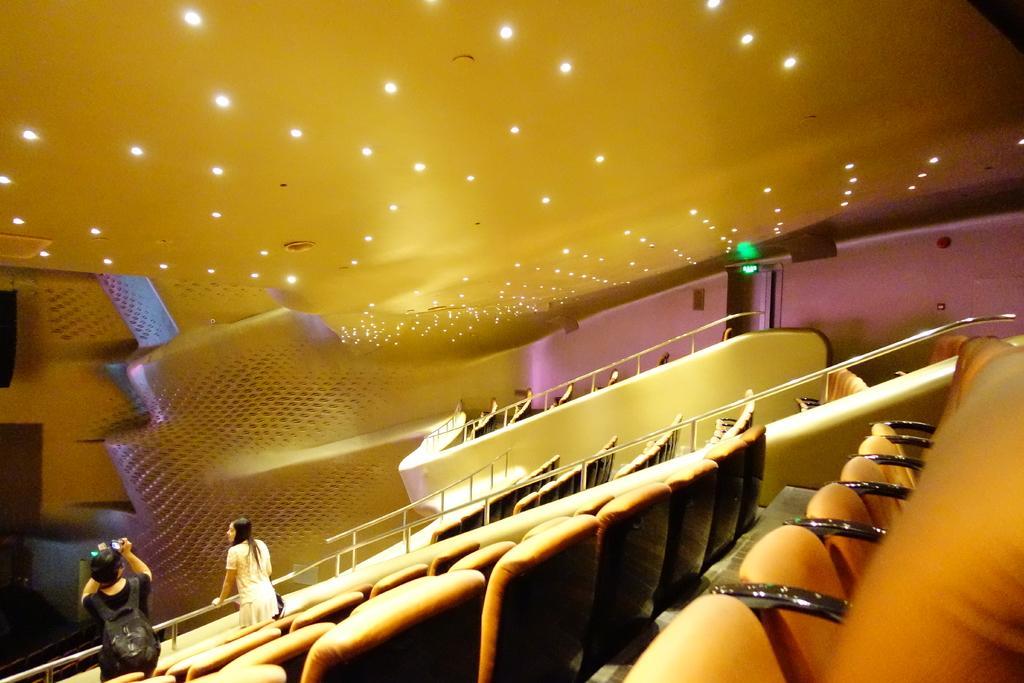How would you summarize this image in a sentence or two? In this image, I can see the chairs. At the bottom of the image, I can see two people standing. At the top of the image, I can see the ceiling lights. 